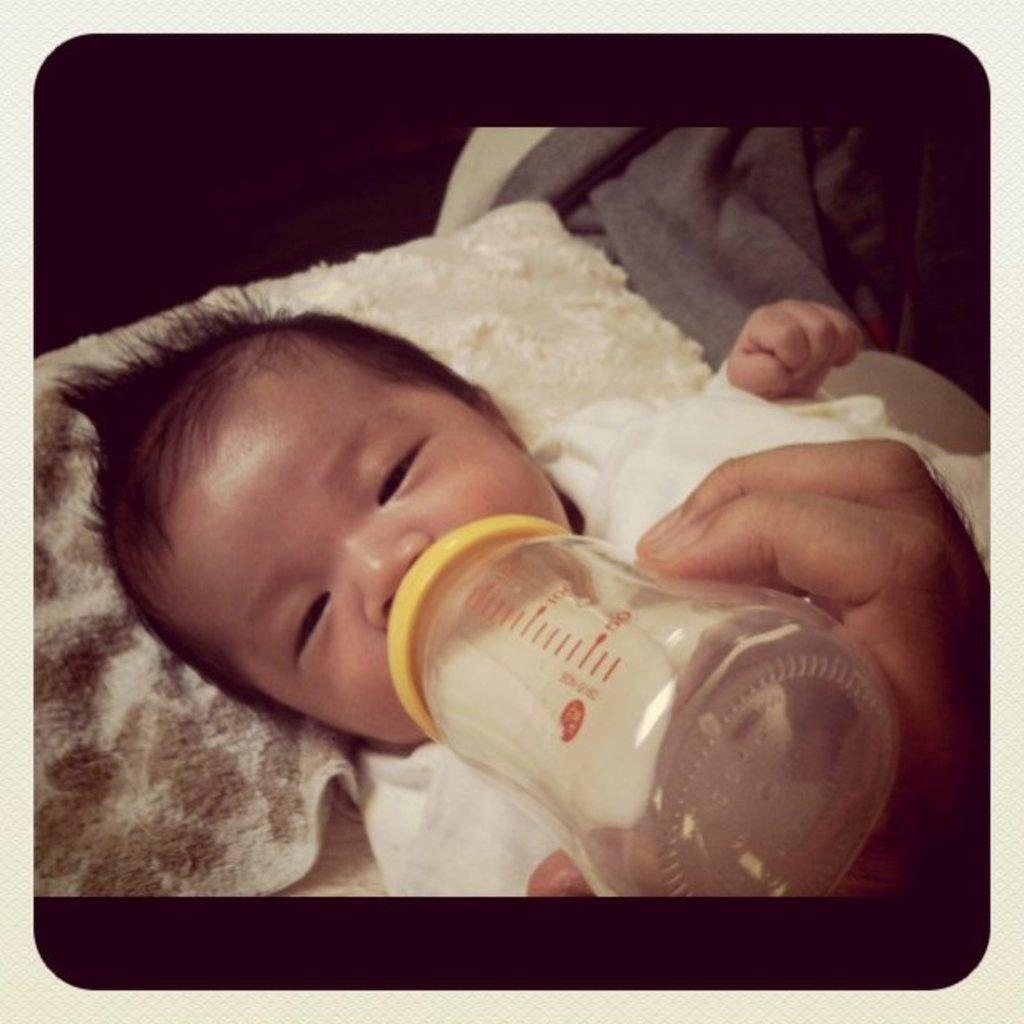What is the main subject of the image? The main subject of the image is a kid. What is the kid doing in the image? The kid is sleeping on the bed. What is the kid holding in the image? The kid is drinking milk from a milk bottle. What is on the right side of the bed? There is a blanket on the right side of the bed. What type of pin can be seen holding the kid's blanket in the image? There is no pin present in the image; the blanket is simply placed on the bed. How many pails are visible in the image? There are no pails visible in the image. 